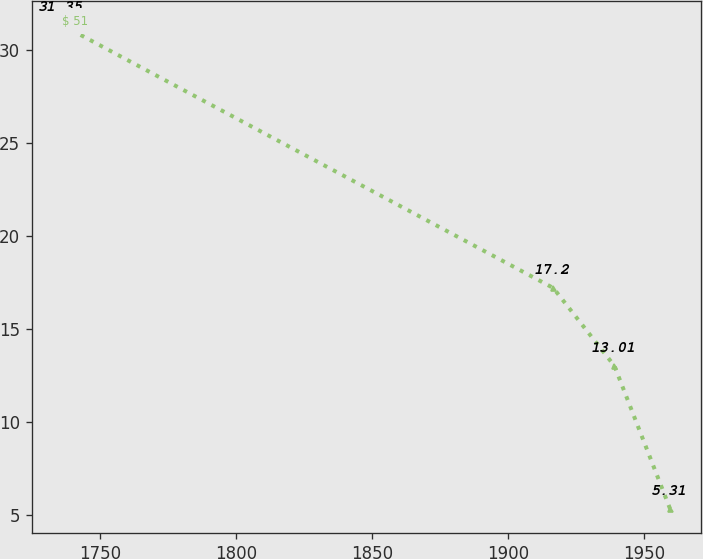Convert chart to OTSL. <chart><loc_0><loc_0><loc_500><loc_500><line_chart><ecel><fcel>$ 51<nl><fcel>1735.94<fcel>31.35<nl><fcel>1916.53<fcel>17.2<nl><fcel>1938.99<fcel>13.01<nl><fcel>1959.47<fcel>5.31<nl></chart> 